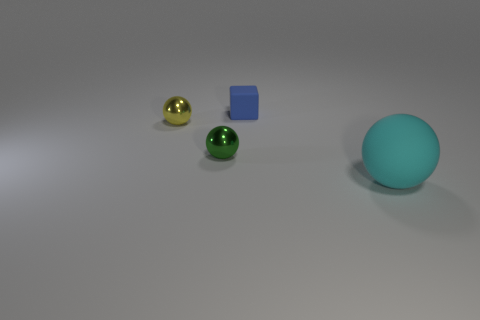Add 4 tiny purple objects. How many objects exist? 8 Subtract all balls. How many objects are left? 1 Add 4 big cyan rubber balls. How many big cyan rubber balls exist? 5 Subtract 1 green balls. How many objects are left? 3 Subtract all yellow balls. Subtract all balls. How many objects are left? 0 Add 1 small yellow balls. How many small yellow balls are left? 2 